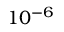<formula> <loc_0><loc_0><loc_500><loc_500>1 0 ^ { - 6 }</formula> 